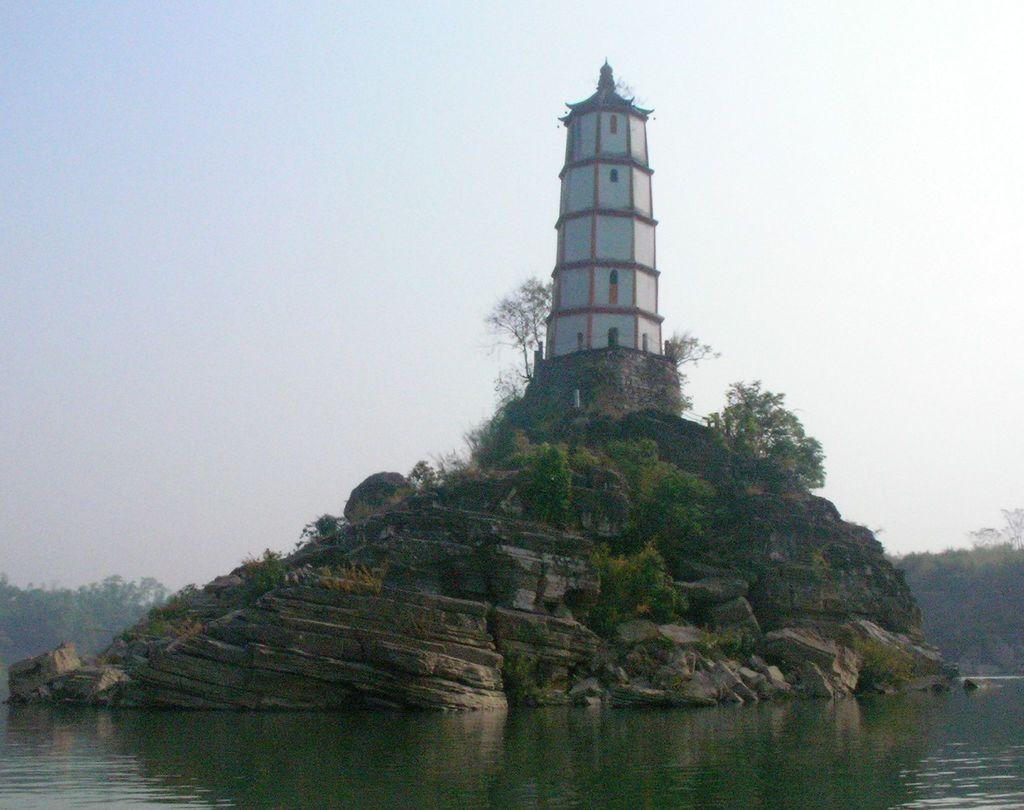How would you summarize this image in a sentence or two? In the center of the image we can see a hill. On hill we can see a building, trees, wall, windows, railing. In the background of the image we can see the trees. At the bottom of the image we can see the water. At the top of the image we can see the sky. 